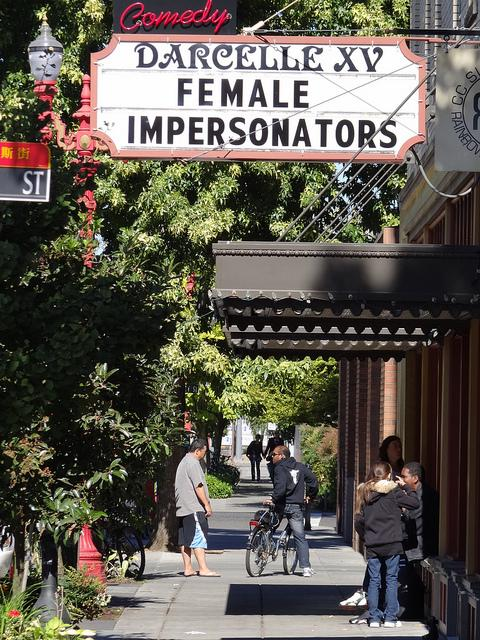Why do they impersonate females? entertainment 